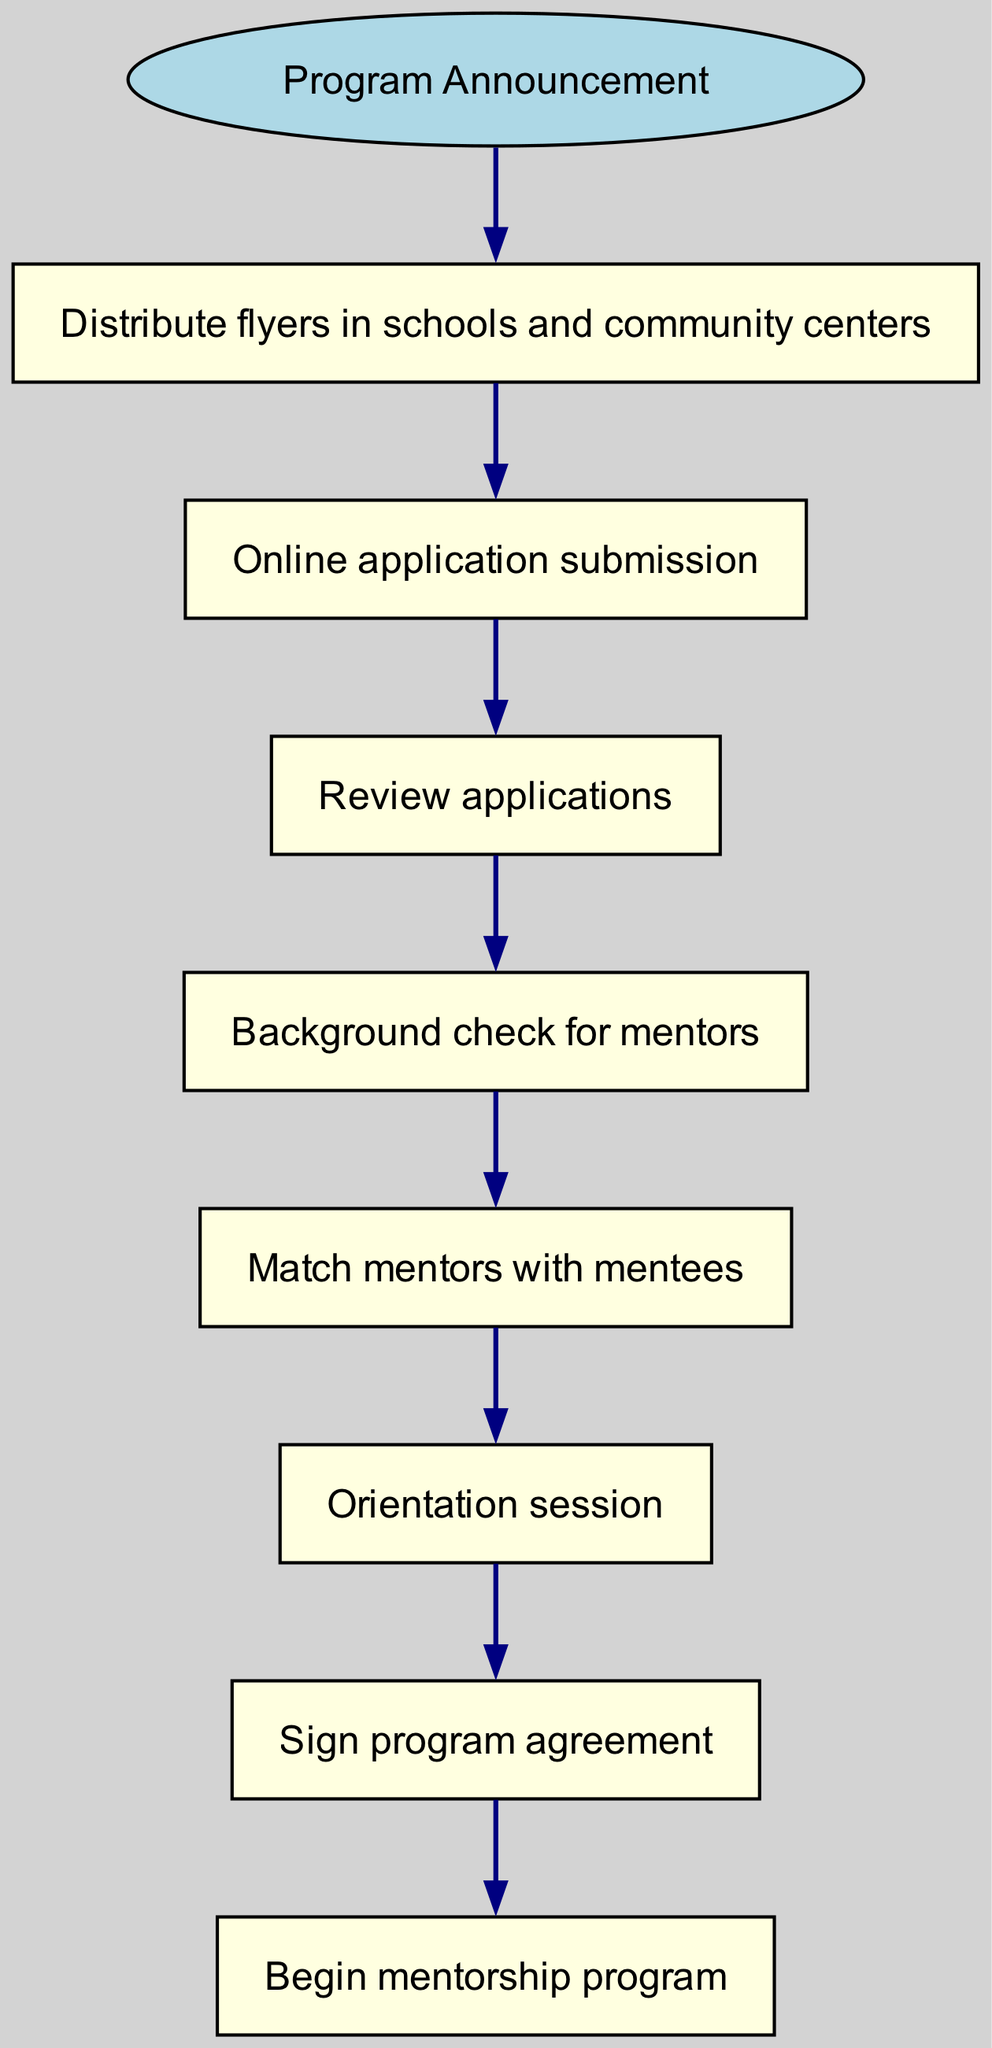What is the first step in the enrollment process? The first step is defined as the node following the "Program Announcement," which is "Distribute flyers in schools and community centers." This is the initial action indicated in the flow chart.
Answer: Distribute flyers in schools and community centers How many total nodes are present in the diagram? The total number of nodes includes the start node and each of the subsequent actions listed in the flow chart. In this case, there are 8 actions plus the start node, totaling 9 nodes.
Answer: 9 What action follows the online application submission? The diagram illustrates that the action occurring immediately after "Online application submission" is "Review applications." This is the next step in the sequence.
Answer: Review applications What is the last step of the enrollment process? The final action in the flow of the diagram is shown as "Begin mentorship program." This is the last node following all prior steps.
Answer: Begin mentorship program Which step involves checking mentor backgrounds? In the flow chart, the node that clearly focuses on mentor screening is "Background check for mentors." This is explicitly described in the sequence of steps.
Answer: Background check for mentors What actions are performed after matching mentors with mentees? The sequence following "Match mentors with mentees" includes "Orientation session" and "Sign program agreement." Both steps occur sequentially after the matching phase.
Answer: Orientation session, Sign program agreement What is the relationship between the "Review applications" and "Background check for mentors"? The flow chart indicates that "Background check for mentors" logically follows "Review applications," meaning that these two nodes are directly connected in sequence.
Answer: Background check for mentors follows Review applications How does one enter the application phase? According to the diagram's structure, entering the application phase is initiated by completing the step "Distribute flyers in schools and community centers," which then leads to an "Online application submission."
Answer: By distributing flyers What is the total number of connections between nodes? Each action corresponds to a pathway or connection leading from one step to another. Counting these connections according to the flow chart, we find there are 8 connections in total.
Answer: 8 